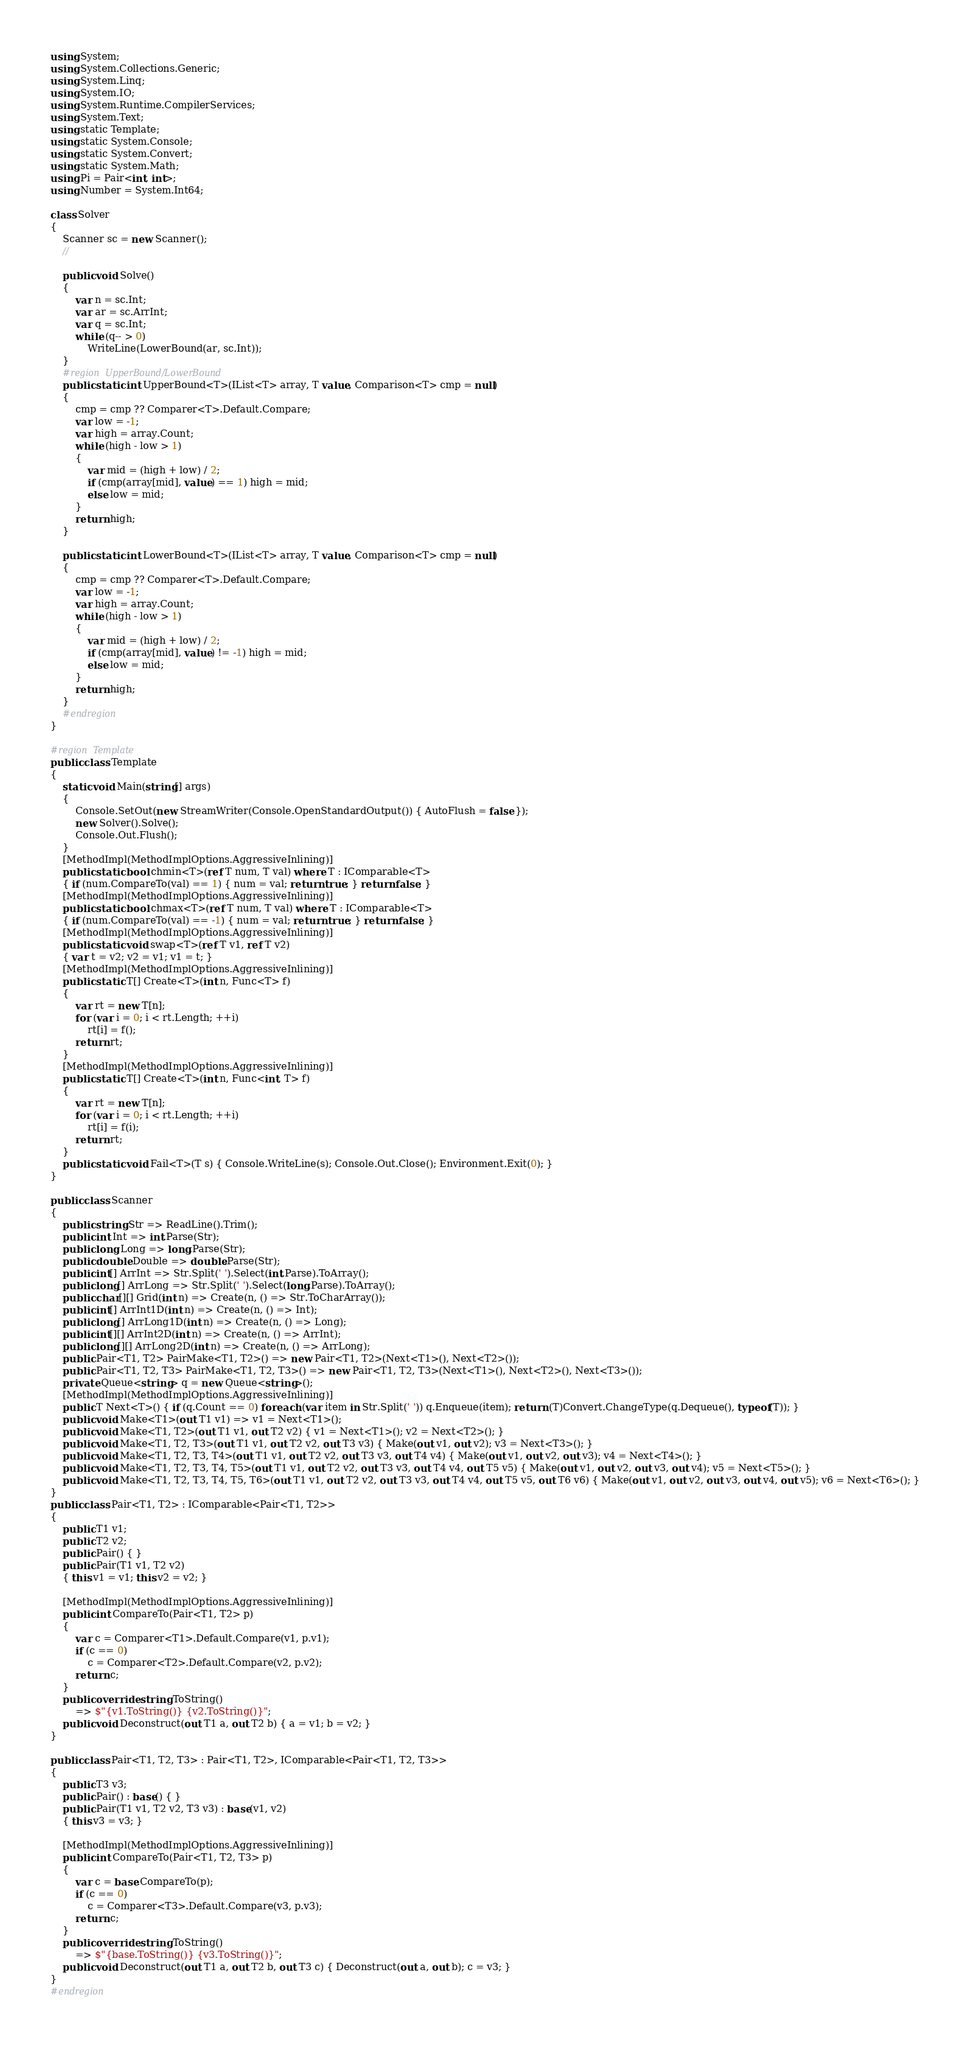Convert code to text. <code><loc_0><loc_0><loc_500><loc_500><_C#_>using System;
using System.Collections.Generic;
using System.Linq;
using System.IO;
using System.Runtime.CompilerServices;
using System.Text;
using static Template;
using static System.Console;
using static System.Convert;
using static System.Math;
using Pi = Pair<int, int>;
using Number = System.Int64;

class Solver
{
    Scanner sc = new Scanner();
    //

    public void Solve()
    {
        var n = sc.Int;
        var ar = sc.ArrInt;
        var q = sc.Int;
        while (q-- > 0)
            WriteLine(LowerBound(ar, sc.Int));
    }
    #region UpperBound/LowerBound
    public static int UpperBound<T>(IList<T> array, T value, Comparison<T> cmp = null)
    {
        cmp = cmp ?? Comparer<T>.Default.Compare;
        var low = -1;
        var high = array.Count;
        while (high - low > 1)
        {
            var mid = (high + low) / 2;
            if (cmp(array[mid], value) == 1) high = mid;
            else low = mid;
        }
        return high;
    }

    public static int LowerBound<T>(IList<T> array, T value, Comparison<T> cmp = null)
    {
        cmp = cmp ?? Comparer<T>.Default.Compare;
        var low = -1;
        var high = array.Count;
        while (high - low > 1)
        {
            var mid = (high + low) / 2;
            if (cmp(array[mid], value) != -1) high = mid;
            else low = mid;
        }
        return high;
    }
    #endregion
}

#region Template
public class Template
{
    static void Main(string[] args)
    {
        Console.SetOut(new StreamWriter(Console.OpenStandardOutput()) { AutoFlush = false });
        new Solver().Solve();
        Console.Out.Flush();
    }
    [MethodImpl(MethodImplOptions.AggressiveInlining)]
    public static bool chmin<T>(ref T num, T val) where T : IComparable<T>
    { if (num.CompareTo(val) == 1) { num = val; return true; } return false; }
    [MethodImpl(MethodImplOptions.AggressiveInlining)]
    public static bool chmax<T>(ref T num, T val) where T : IComparable<T>
    { if (num.CompareTo(val) == -1) { num = val; return true; } return false; }
    [MethodImpl(MethodImplOptions.AggressiveInlining)]
    public static void swap<T>(ref T v1, ref T v2)
    { var t = v2; v2 = v1; v1 = t; }
    [MethodImpl(MethodImplOptions.AggressiveInlining)]
    public static T[] Create<T>(int n, Func<T> f)
    {
        var rt = new T[n];
        for (var i = 0; i < rt.Length; ++i)
            rt[i] = f();
        return rt;
    }
    [MethodImpl(MethodImplOptions.AggressiveInlining)]
    public static T[] Create<T>(int n, Func<int, T> f)
    {
        var rt = new T[n];
        for (var i = 0; i < rt.Length; ++i)
            rt[i] = f(i);
        return rt;
    }
    public static void Fail<T>(T s) { Console.WriteLine(s); Console.Out.Close(); Environment.Exit(0); }
}

public class Scanner
{
    public string Str => ReadLine().Trim();
    public int Int => int.Parse(Str);
    public long Long => long.Parse(Str);
    public double Double => double.Parse(Str);
    public int[] ArrInt => Str.Split(' ').Select(int.Parse).ToArray();
    public long[] ArrLong => Str.Split(' ').Select(long.Parse).ToArray();
    public char[][] Grid(int n) => Create(n, () => Str.ToCharArray());
    public int[] ArrInt1D(int n) => Create(n, () => Int);
    public long[] ArrLong1D(int n) => Create(n, () => Long);
    public int[][] ArrInt2D(int n) => Create(n, () => ArrInt);
    public long[][] ArrLong2D(int n) => Create(n, () => ArrLong);
    public Pair<T1, T2> PairMake<T1, T2>() => new Pair<T1, T2>(Next<T1>(), Next<T2>());
    public Pair<T1, T2, T3> PairMake<T1, T2, T3>() => new Pair<T1, T2, T3>(Next<T1>(), Next<T2>(), Next<T3>());
    private Queue<string> q = new Queue<string>();
    [MethodImpl(MethodImplOptions.AggressiveInlining)]
    public T Next<T>() { if (q.Count == 0) foreach (var item in Str.Split(' ')) q.Enqueue(item); return (T)Convert.ChangeType(q.Dequeue(), typeof(T)); }
    public void Make<T1>(out T1 v1) => v1 = Next<T1>();
    public void Make<T1, T2>(out T1 v1, out T2 v2) { v1 = Next<T1>(); v2 = Next<T2>(); }
    public void Make<T1, T2, T3>(out T1 v1, out T2 v2, out T3 v3) { Make(out v1, out v2); v3 = Next<T3>(); }
    public void Make<T1, T2, T3, T4>(out T1 v1, out T2 v2, out T3 v3, out T4 v4) { Make(out v1, out v2, out v3); v4 = Next<T4>(); }
    public void Make<T1, T2, T3, T4, T5>(out T1 v1, out T2 v2, out T3 v3, out T4 v4, out T5 v5) { Make(out v1, out v2, out v3, out v4); v5 = Next<T5>(); }
    public void Make<T1, T2, T3, T4, T5, T6>(out T1 v1, out T2 v2, out T3 v3, out T4 v4, out T5 v5, out T6 v6) { Make(out v1, out v2, out v3, out v4, out v5); v6 = Next<T6>(); }
}
public class Pair<T1, T2> : IComparable<Pair<T1, T2>>
{
    public T1 v1;
    public T2 v2;
    public Pair() { }
    public Pair(T1 v1, T2 v2)
    { this.v1 = v1; this.v2 = v2; }

    [MethodImpl(MethodImplOptions.AggressiveInlining)]
    public int CompareTo(Pair<T1, T2> p)
    {
        var c = Comparer<T1>.Default.Compare(v1, p.v1);
        if (c == 0)
            c = Comparer<T2>.Default.Compare(v2, p.v2);
        return c;
    }
    public override string ToString()
        => $"{v1.ToString()} {v2.ToString()}";
    public void Deconstruct(out T1 a, out T2 b) { a = v1; b = v2; }
}

public class Pair<T1, T2, T3> : Pair<T1, T2>, IComparable<Pair<T1, T2, T3>>
{
    public T3 v3;
    public Pair() : base() { }
    public Pair(T1 v1, T2 v2, T3 v3) : base(v1, v2)
    { this.v3 = v3; }

    [MethodImpl(MethodImplOptions.AggressiveInlining)]
    public int CompareTo(Pair<T1, T2, T3> p)
    {
        var c = base.CompareTo(p);
        if (c == 0)
            c = Comparer<T3>.Default.Compare(v3, p.v3);
        return c;
    }
    public override string ToString()
        => $"{base.ToString()} {v3.ToString()}";
    public void Deconstruct(out T1 a, out T2 b, out T3 c) { Deconstruct(out a, out b); c = v3; }
}
#endregion

</code> 